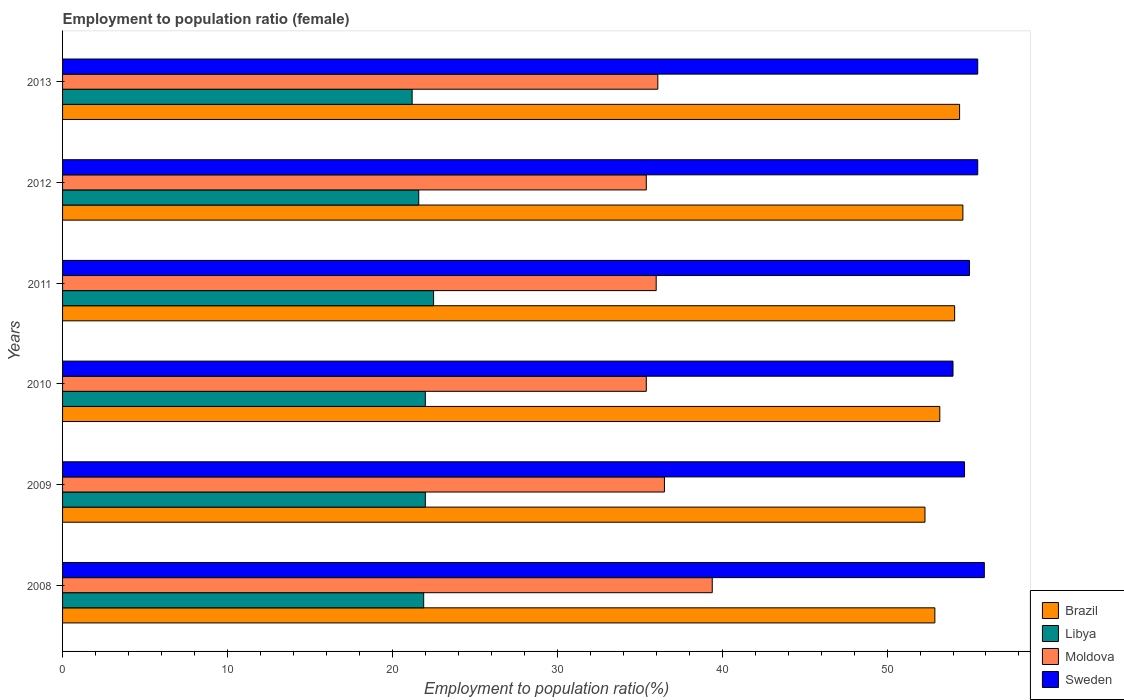Are the number of bars on each tick of the Y-axis equal?
Offer a very short reply. Yes. How many bars are there on the 3rd tick from the top?
Your answer should be very brief. 4. How many bars are there on the 4th tick from the bottom?
Give a very brief answer. 4. In how many cases, is the number of bars for a given year not equal to the number of legend labels?
Offer a very short reply. 0. What is the employment to population ratio in Brazil in 2011?
Provide a succinct answer. 54.1. Across all years, what is the minimum employment to population ratio in Brazil?
Offer a very short reply. 52.3. In which year was the employment to population ratio in Moldova maximum?
Your answer should be very brief. 2008. What is the total employment to population ratio in Sweden in the graph?
Provide a short and direct response. 330.6. What is the difference between the employment to population ratio in Brazil in 2012 and that in 2013?
Provide a short and direct response. 0.2. What is the difference between the employment to population ratio in Brazil in 2011 and the employment to population ratio in Moldova in 2012?
Keep it short and to the point. 18.7. What is the average employment to population ratio in Sweden per year?
Provide a short and direct response. 55.1. In the year 2009, what is the difference between the employment to population ratio in Libya and employment to population ratio in Sweden?
Make the answer very short. -32.7. What is the ratio of the employment to population ratio in Libya in 2011 to that in 2013?
Your answer should be very brief. 1.06. Is the difference between the employment to population ratio in Libya in 2009 and 2011 greater than the difference between the employment to population ratio in Sweden in 2009 and 2011?
Make the answer very short. No. What is the difference between the highest and the lowest employment to population ratio in Brazil?
Make the answer very short. 2.3. In how many years, is the employment to population ratio in Moldova greater than the average employment to population ratio in Moldova taken over all years?
Give a very brief answer. 2. Is the sum of the employment to population ratio in Libya in 2008 and 2012 greater than the maximum employment to population ratio in Moldova across all years?
Ensure brevity in your answer.  Yes. What does the 2nd bar from the bottom in 2008 represents?
Offer a terse response. Libya. Is it the case that in every year, the sum of the employment to population ratio in Brazil and employment to population ratio in Moldova is greater than the employment to population ratio in Sweden?
Offer a terse response. Yes. How many bars are there?
Provide a succinct answer. 24. Are all the bars in the graph horizontal?
Offer a very short reply. Yes. What is the difference between two consecutive major ticks on the X-axis?
Your answer should be compact. 10. Does the graph contain any zero values?
Keep it short and to the point. No. Does the graph contain grids?
Make the answer very short. No. How are the legend labels stacked?
Your response must be concise. Vertical. What is the title of the graph?
Keep it short and to the point. Employment to population ratio (female). Does "Iceland" appear as one of the legend labels in the graph?
Your answer should be compact. No. What is the Employment to population ratio(%) in Brazil in 2008?
Give a very brief answer. 52.9. What is the Employment to population ratio(%) of Libya in 2008?
Ensure brevity in your answer.  21.9. What is the Employment to population ratio(%) in Moldova in 2008?
Offer a very short reply. 39.4. What is the Employment to population ratio(%) in Sweden in 2008?
Provide a short and direct response. 55.9. What is the Employment to population ratio(%) of Brazil in 2009?
Your answer should be very brief. 52.3. What is the Employment to population ratio(%) of Libya in 2009?
Give a very brief answer. 22. What is the Employment to population ratio(%) of Moldova in 2009?
Keep it short and to the point. 36.5. What is the Employment to population ratio(%) of Sweden in 2009?
Keep it short and to the point. 54.7. What is the Employment to population ratio(%) of Brazil in 2010?
Your answer should be very brief. 53.2. What is the Employment to population ratio(%) in Libya in 2010?
Keep it short and to the point. 22. What is the Employment to population ratio(%) in Moldova in 2010?
Offer a terse response. 35.4. What is the Employment to population ratio(%) of Sweden in 2010?
Make the answer very short. 54. What is the Employment to population ratio(%) of Brazil in 2011?
Provide a succinct answer. 54.1. What is the Employment to population ratio(%) of Brazil in 2012?
Provide a succinct answer. 54.6. What is the Employment to population ratio(%) in Libya in 2012?
Give a very brief answer. 21.6. What is the Employment to population ratio(%) in Moldova in 2012?
Give a very brief answer. 35.4. What is the Employment to population ratio(%) of Sweden in 2012?
Provide a short and direct response. 55.5. What is the Employment to population ratio(%) of Brazil in 2013?
Your response must be concise. 54.4. What is the Employment to population ratio(%) of Libya in 2013?
Your answer should be very brief. 21.2. What is the Employment to population ratio(%) in Moldova in 2013?
Your answer should be very brief. 36.1. What is the Employment to population ratio(%) in Sweden in 2013?
Provide a short and direct response. 55.5. Across all years, what is the maximum Employment to population ratio(%) of Brazil?
Provide a succinct answer. 54.6. Across all years, what is the maximum Employment to population ratio(%) of Libya?
Make the answer very short. 22.5. Across all years, what is the maximum Employment to population ratio(%) in Moldova?
Give a very brief answer. 39.4. Across all years, what is the maximum Employment to population ratio(%) in Sweden?
Your answer should be very brief. 55.9. Across all years, what is the minimum Employment to population ratio(%) of Brazil?
Provide a short and direct response. 52.3. Across all years, what is the minimum Employment to population ratio(%) of Libya?
Offer a very short reply. 21.2. Across all years, what is the minimum Employment to population ratio(%) of Moldova?
Your response must be concise. 35.4. What is the total Employment to population ratio(%) in Brazil in the graph?
Your answer should be compact. 321.5. What is the total Employment to population ratio(%) of Libya in the graph?
Offer a very short reply. 131.2. What is the total Employment to population ratio(%) in Moldova in the graph?
Ensure brevity in your answer.  218.8. What is the total Employment to population ratio(%) of Sweden in the graph?
Your answer should be very brief. 330.6. What is the difference between the Employment to population ratio(%) of Sweden in 2008 and that in 2009?
Offer a terse response. 1.2. What is the difference between the Employment to population ratio(%) in Moldova in 2008 and that in 2010?
Offer a very short reply. 4. What is the difference between the Employment to population ratio(%) in Brazil in 2008 and that in 2012?
Offer a very short reply. -1.7. What is the difference between the Employment to population ratio(%) in Brazil in 2008 and that in 2013?
Provide a succinct answer. -1.5. What is the difference between the Employment to population ratio(%) in Brazil in 2009 and that in 2010?
Make the answer very short. -0.9. What is the difference between the Employment to population ratio(%) of Libya in 2009 and that in 2010?
Keep it short and to the point. 0. What is the difference between the Employment to population ratio(%) of Moldova in 2009 and that in 2010?
Your response must be concise. 1.1. What is the difference between the Employment to population ratio(%) in Sweden in 2009 and that in 2010?
Your answer should be compact. 0.7. What is the difference between the Employment to population ratio(%) in Brazil in 2009 and that in 2012?
Your response must be concise. -2.3. What is the difference between the Employment to population ratio(%) in Libya in 2009 and that in 2012?
Ensure brevity in your answer.  0.4. What is the difference between the Employment to population ratio(%) in Moldova in 2009 and that in 2012?
Offer a very short reply. 1.1. What is the difference between the Employment to population ratio(%) in Moldova in 2009 and that in 2013?
Ensure brevity in your answer.  0.4. What is the difference between the Employment to population ratio(%) in Sweden in 2009 and that in 2013?
Offer a terse response. -0.8. What is the difference between the Employment to population ratio(%) in Libya in 2010 and that in 2011?
Give a very brief answer. -0.5. What is the difference between the Employment to population ratio(%) of Moldova in 2010 and that in 2011?
Make the answer very short. -0.6. What is the difference between the Employment to population ratio(%) in Brazil in 2010 and that in 2012?
Your response must be concise. -1.4. What is the difference between the Employment to population ratio(%) of Libya in 2010 and that in 2013?
Offer a terse response. 0.8. What is the difference between the Employment to population ratio(%) in Sweden in 2010 and that in 2013?
Keep it short and to the point. -1.5. What is the difference between the Employment to population ratio(%) of Sweden in 2011 and that in 2012?
Give a very brief answer. -0.5. What is the difference between the Employment to population ratio(%) in Brazil in 2011 and that in 2013?
Offer a very short reply. -0.3. What is the difference between the Employment to population ratio(%) of Libya in 2011 and that in 2013?
Keep it short and to the point. 1.3. What is the difference between the Employment to population ratio(%) of Moldova in 2011 and that in 2013?
Make the answer very short. -0.1. What is the difference between the Employment to population ratio(%) of Sweden in 2011 and that in 2013?
Provide a succinct answer. -0.5. What is the difference between the Employment to population ratio(%) in Libya in 2012 and that in 2013?
Ensure brevity in your answer.  0.4. What is the difference between the Employment to population ratio(%) in Brazil in 2008 and the Employment to population ratio(%) in Libya in 2009?
Make the answer very short. 30.9. What is the difference between the Employment to population ratio(%) in Brazil in 2008 and the Employment to population ratio(%) in Sweden in 2009?
Your answer should be very brief. -1.8. What is the difference between the Employment to population ratio(%) in Libya in 2008 and the Employment to population ratio(%) in Moldova in 2009?
Provide a succinct answer. -14.6. What is the difference between the Employment to population ratio(%) in Libya in 2008 and the Employment to population ratio(%) in Sweden in 2009?
Offer a very short reply. -32.8. What is the difference between the Employment to population ratio(%) of Moldova in 2008 and the Employment to population ratio(%) of Sweden in 2009?
Provide a short and direct response. -15.3. What is the difference between the Employment to population ratio(%) in Brazil in 2008 and the Employment to population ratio(%) in Libya in 2010?
Your answer should be compact. 30.9. What is the difference between the Employment to population ratio(%) of Brazil in 2008 and the Employment to population ratio(%) of Sweden in 2010?
Offer a very short reply. -1.1. What is the difference between the Employment to population ratio(%) in Libya in 2008 and the Employment to population ratio(%) in Sweden in 2010?
Offer a very short reply. -32.1. What is the difference between the Employment to population ratio(%) in Moldova in 2008 and the Employment to population ratio(%) in Sweden in 2010?
Provide a succinct answer. -14.6. What is the difference between the Employment to population ratio(%) of Brazil in 2008 and the Employment to population ratio(%) of Libya in 2011?
Make the answer very short. 30.4. What is the difference between the Employment to population ratio(%) in Libya in 2008 and the Employment to population ratio(%) in Moldova in 2011?
Make the answer very short. -14.1. What is the difference between the Employment to population ratio(%) of Libya in 2008 and the Employment to population ratio(%) of Sweden in 2011?
Offer a terse response. -33.1. What is the difference between the Employment to population ratio(%) in Moldova in 2008 and the Employment to population ratio(%) in Sweden in 2011?
Ensure brevity in your answer.  -15.6. What is the difference between the Employment to population ratio(%) in Brazil in 2008 and the Employment to population ratio(%) in Libya in 2012?
Keep it short and to the point. 31.3. What is the difference between the Employment to population ratio(%) of Libya in 2008 and the Employment to population ratio(%) of Sweden in 2012?
Ensure brevity in your answer.  -33.6. What is the difference between the Employment to population ratio(%) of Moldova in 2008 and the Employment to population ratio(%) of Sweden in 2012?
Make the answer very short. -16.1. What is the difference between the Employment to population ratio(%) of Brazil in 2008 and the Employment to population ratio(%) of Libya in 2013?
Your answer should be compact. 31.7. What is the difference between the Employment to population ratio(%) of Brazil in 2008 and the Employment to population ratio(%) of Sweden in 2013?
Offer a terse response. -2.6. What is the difference between the Employment to population ratio(%) in Libya in 2008 and the Employment to population ratio(%) in Sweden in 2013?
Your response must be concise. -33.6. What is the difference between the Employment to population ratio(%) in Moldova in 2008 and the Employment to population ratio(%) in Sweden in 2013?
Give a very brief answer. -16.1. What is the difference between the Employment to population ratio(%) in Brazil in 2009 and the Employment to population ratio(%) in Libya in 2010?
Provide a succinct answer. 30.3. What is the difference between the Employment to population ratio(%) in Brazil in 2009 and the Employment to population ratio(%) in Moldova in 2010?
Make the answer very short. 16.9. What is the difference between the Employment to population ratio(%) of Libya in 2009 and the Employment to population ratio(%) of Sweden in 2010?
Give a very brief answer. -32. What is the difference between the Employment to population ratio(%) in Moldova in 2009 and the Employment to population ratio(%) in Sweden in 2010?
Offer a very short reply. -17.5. What is the difference between the Employment to population ratio(%) in Brazil in 2009 and the Employment to population ratio(%) in Libya in 2011?
Give a very brief answer. 29.8. What is the difference between the Employment to population ratio(%) in Brazil in 2009 and the Employment to population ratio(%) in Moldova in 2011?
Your response must be concise. 16.3. What is the difference between the Employment to population ratio(%) in Brazil in 2009 and the Employment to population ratio(%) in Sweden in 2011?
Give a very brief answer. -2.7. What is the difference between the Employment to population ratio(%) in Libya in 2009 and the Employment to population ratio(%) in Sweden in 2011?
Your answer should be very brief. -33. What is the difference between the Employment to population ratio(%) of Moldova in 2009 and the Employment to population ratio(%) of Sweden in 2011?
Ensure brevity in your answer.  -18.5. What is the difference between the Employment to population ratio(%) of Brazil in 2009 and the Employment to population ratio(%) of Libya in 2012?
Your answer should be very brief. 30.7. What is the difference between the Employment to population ratio(%) in Brazil in 2009 and the Employment to population ratio(%) in Moldova in 2012?
Provide a short and direct response. 16.9. What is the difference between the Employment to population ratio(%) of Brazil in 2009 and the Employment to population ratio(%) of Sweden in 2012?
Give a very brief answer. -3.2. What is the difference between the Employment to population ratio(%) of Libya in 2009 and the Employment to population ratio(%) of Sweden in 2012?
Offer a terse response. -33.5. What is the difference between the Employment to population ratio(%) of Brazil in 2009 and the Employment to population ratio(%) of Libya in 2013?
Ensure brevity in your answer.  31.1. What is the difference between the Employment to population ratio(%) in Libya in 2009 and the Employment to population ratio(%) in Moldova in 2013?
Offer a terse response. -14.1. What is the difference between the Employment to population ratio(%) in Libya in 2009 and the Employment to population ratio(%) in Sweden in 2013?
Ensure brevity in your answer.  -33.5. What is the difference between the Employment to population ratio(%) in Brazil in 2010 and the Employment to population ratio(%) in Libya in 2011?
Your answer should be compact. 30.7. What is the difference between the Employment to population ratio(%) in Brazil in 2010 and the Employment to population ratio(%) in Moldova in 2011?
Make the answer very short. 17.2. What is the difference between the Employment to population ratio(%) in Brazil in 2010 and the Employment to population ratio(%) in Sweden in 2011?
Offer a very short reply. -1.8. What is the difference between the Employment to population ratio(%) of Libya in 2010 and the Employment to population ratio(%) of Sweden in 2011?
Give a very brief answer. -33. What is the difference between the Employment to population ratio(%) in Moldova in 2010 and the Employment to population ratio(%) in Sweden in 2011?
Your answer should be very brief. -19.6. What is the difference between the Employment to population ratio(%) of Brazil in 2010 and the Employment to population ratio(%) of Libya in 2012?
Make the answer very short. 31.6. What is the difference between the Employment to population ratio(%) in Brazil in 2010 and the Employment to population ratio(%) in Sweden in 2012?
Ensure brevity in your answer.  -2.3. What is the difference between the Employment to population ratio(%) of Libya in 2010 and the Employment to population ratio(%) of Moldova in 2012?
Offer a terse response. -13.4. What is the difference between the Employment to population ratio(%) in Libya in 2010 and the Employment to population ratio(%) in Sweden in 2012?
Provide a short and direct response. -33.5. What is the difference between the Employment to population ratio(%) of Moldova in 2010 and the Employment to population ratio(%) of Sweden in 2012?
Make the answer very short. -20.1. What is the difference between the Employment to population ratio(%) in Libya in 2010 and the Employment to population ratio(%) in Moldova in 2013?
Offer a very short reply. -14.1. What is the difference between the Employment to population ratio(%) of Libya in 2010 and the Employment to population ratio(%) of Sweden in 2013?
Give a very brief answer. -33.5. What is the difference between the Employment to population ratio(%) of Moldova in 2010 and the Employment to population ratio(%) of Sweden in 2013?
Keep it short and to the point. -20.1. What is the difference between the Employment to population ratio(%) in Brazil in 2011 and the Employment to population ratio(%) in Libya in 2012?
Offer a very short reply. 32.5. What is the difference between the Employment to population ratio(%) in Brazil in 2011 and the Employment to population ratio(%) in Sweden in 2012?
Your answer should be very brief. -1.4. What is the difference between the Employment to population ratio(%) of Libya in 2011 and the Employment to population ratio(%) of Sweden in 2012?
Your answer should be compact. -33. What is the difference between the Employment to population ratio(%) in Moldova in 2011 and the Employment to population ratio(%) in Sweden in 2012?
Provide a succinct answer. -19.5. What is the difference between the Employment to population ratio(%) in Brazil in 2011 and the Employment to population ratio(%) in Libya in 2013?
Your answer should be compact. 32.9. What is the difference between the Employment to population ratio(%) in Libya in 2011 and the Employment to population ratio(%) in Moldova in 2013?
Make the answer very short. -13.6. What is the difference between the Employment to population ratio(%) of Libya in 2011 and the Employment to population ratio(%) of Sweden in 2013?
Your answer should be very brief. -33. What is the difference between the Employment to population ratio(%) in Moldova in 2011 and the Employment to population ratio(%) in Sweden in 2013?
Your answer should be very brief. -19.5. What is the difference between the Employment to population ratio(%) in Brazil in 2012 and the Employment to population ratio(%) in Libya in 2013?
Ensure brevity in your answer.  33.4. What is the difference between the Employment to population ratio(%) of Libya in 2012 and the Employment to population ratio(%) of Moldova in 2013?
Ensure brevity in your answer.  -14.5. What is the difference between the Employment to population ratio(%) of Libya in 2012 and the Employment to population ratio(%) of Sweden in 2013?
Offer a terse response. -33.9. What is the difference between the Employment to population ratio(%) in Moldova in 2012 and the Employment to population ratio(%) in Sweden in 2013?
Offer a very short reply. -20.1. What is the average Employment to population ratio(%) of Brazil per year?
Ensure brevity in your answer.  53.58. What is the average Employment to population ratio(%) in Libya per year?
Your answer should be compact. 21.87. What is the average Employment to population ratio(%) of Moldova per year?
Give a very brief answer. 36.47. What is the average Employment to population ratio(%) in Sweden per year?
Provide a succinct answer. 55.1. In the year 2008, what is the difference between the Employment to population ratio(%) of Brazil and Employment to population ratio(%) of Libya?
Ensure brevity in your answer.  31. In the year 2008, what is the difference between the Employment to population ratio(%) in Libya and Employment to population ratio(%) in Moldova?
Your response must be concise. -17.5. In the year 2008, what is the difference between the Employment to population ratio(%) of Libya and Employment to population ratio(%) of Sweden?
Give a very brief answer. -34. In the year 2008, what is the difference between the Employment to population ratio(%) of Moldova and Employment to population ratio(%) of Sweden?
Make the answer very short. -16.5. In the year 2009, what is the difference between the Employment to population ratio(%) in Brazil and Employment to population ratio(%) in Libya?
Offer a very short reply. 30.3. In the year 2009, what is the difference between the Employment to population ratio(%) of Brazil and Employment to population ratio(%) of Moldova?
Your response must be concise. 15.8. In the year 2009, what is the difference between the Employment to population ratio(%) in Libya and Employment to population ratio(%) in Moldova?
Give a very brief answer. -14.5. In the year 2009, what is the difference between the Employment to population ratio(%) of Libya and Employment to population ratio(%) of Sweden?
Ensure brevity in your answer.  -32.7. In the year 2009, what is the difference between the Employment to population ratio(%) of Moldova and Employment to population ratio(%) of Sweden?
Offer a terse response. -18.2. In the year 2010, what is the difference between the Employment to population ratio(%) in Brazil and Employment to population ratio(%) in Libya?
Offer a very short reply. 31.2. In the year 2010, what is the difference between the Employment to population ratio(%) of Libya and Employment to population ratio(%) of Moldova?
Your response must be concise. -13.4. In the year 2010, what is the difference between the Employment to population ratio(%) in Libya and Employment to population ratio(%) in Sweden?
Provide a short and direct response. -32. In the year 2010, what is the difference between the Employment to population ratio(%) in Moldova and Employment to population ratio(%) in Sweden?
Give a very brief answer. -18.6. In the year 2011, what is the difference between the Employment to population ratio(%) in Brazil and Employment to population ratio(%) in Libya?
Give a very brief answer. 31.6. In the year 2011, what is the difference between the Employment to population ratio(%) of Brazil and Employment to population ratio(%) of Moldova?
Offer a terse response. 18.1. In the year 2011, what is the difference between the Employment to population ratio(%) in Libya and Employment to population ratio(%) in Moldova?
Your response must be concise. -13.5. In the year 2011, what is the difference between the Employment to population ratio(%) of Libya and Employment to population ratio(%) of Sweden?
Ensure brevity in your answer.  -32.5. In the year 2012, what is the difference between the Employment to population ratio(%) in Brazil and Employment to population ratio(%) in Sweden?
Offer a very short reply. -0.9. In the year 2012, what is the difference between the Employment to population ratio(%) in Libya and Employment to population ratio(%) in Moldova?
Make the answer very short. -13.8. In the year 2012, what is the difference between the Employment to population ratio(%) of Libya and Employment to population ratio(%) of Sweden?
Keep it short and to the point. -33.9. In the year 2012, what is the difference between the Employment to population ratio(%) in Moldova and Employment to population ratio(%) in Sweden?
Make the answer very short. -20.1. In the year 2013, what is the difference between the Employment to population ratio(%) in Brazil and Employment to population ratio(%) in Libya?
Your answer should be compact. 33.2. In the year 2013, what is the difference between the Employment to population ratio(%) in Brazil and Employment to population ratio(%) in Moldova?
Your answer should be compact. 18.3. In the year 2013, what is the difference between the Employment to population ratio(%) in Libya and Employment to population ratio(%) in Moldova?
Provide a short and direct response. -14.9. In the year 2013, what is the difference between the Employment to population ratio(%) of Libya and Employment to population ratio(%) of Sweden?
Keep it short and to the point. -34.3. In the year 2013, what is the difference between the Employment to population ratio(%) of Moldova and Employment to population ratio(%) of Sweden?
Offer a very short reply. -19.4. What is the ratio of the Employment to population ratio(%) of Brazil in 2008 to that in 2009?
Keep it short and to the point. 1.01. What is the ratio of the Employment to population ratio(%) in Moldova in 2008 to that in 2009?
Keep it short and to the point. 1.08. What is the ratio of the Employment to population ratio(%) in Sweden in 2008 to that in 2009?
Give a very brief answer. 1.02. What is the ratio of the Employment to population ratio(%) of Brazil in 2008 to that in 2010?
Provide a succinct answer. 0.99. What is the ratio of the Employment to population ratio(%) in Moldova in 2008 to that in 2010?
Your answer should be very brief. 1.11. What is the ratio of the Employment to population ratio(%) of Sweden in 2008 to that in 2010?
Keep it short and to the point. 1.04. What is the ratio of the Employment to population ratio(%) in Brazil in 2008 to that in 2011?
Offer a terse response. 0.98. What is the ratio of the Employment to population ratio(%) in Libya in 2008 to that in 2011?
Offer a terse response. 0.97. What is the ratio of the Employment to population ratio(%) of Moldova in 2008 to that in 2011?
Ensure brevity in your answer.  1.09. What is the ratio of the Employment to population ratio(%) of Sweden in 2008 to that in 2011?
Offer a terse response. 1.02. What is the ratio of the Employment to population ratio(%) of Brazil in 2008 to that in 2012?
Your response must be concise. 0.97. What is the ratio of the Employment to population ratio(%) in Libya in 2008 to that in 2012?
Offer a terse response. 1.01. What is the ratio of the Employment to population ratio(%) of Moldova in 2008 to that in 2012?
Provide a succinct answer. 1.11. What is the ratio of the Employment to population ratio(%) in Brazil in 2008 to that in 2013?
Your answer should be compact. 0.97. What is the ratio of the Employment to population ratio(%) in Libya in 2008 to that in 2013?
Keep it short and to the point. 1.03. What is the ratio of the Employment to population ratio(%) in Moldova in 2008 to that in 2013?
Offer a very short reply. 1.09. What is the ratio of the Employment to population ratio(%) of Sweden in 2008 to that in 2013?
Your response must be concise. 1.01. What is the ratio of the Employment to population ratio(%) of Brazil in 2009 to that in 2010?
Keep it short and to the point. 0.98. What is the ratio of the Employment to population ratio(%) in Libya in 2009 to that in 2010?
Your answer should be compact. 1. What is the ratio of the Employment to population ratio(%) of Moldova in 2009 to that in 2010?
Make the answer very short. 1.03. What is the ratio of the Employment to population ratio(%) in Brazil in 2009 to that in 2011?
Offer a very short reply. 0.97. What is the ratio of the Employment to population ratio(%) of Libya in 2009 to that in 2011?
Provide a succinct answer. 0.98. What is the ratio of the Employment to population ratio(%) in Moldova in 2009 to that in 2011?
Provide a short and direct response. 1.01. What is the ratio of the Employment to population ratio(%) of Brazil in 2009 to that in 2012?
Keep it short and to the point. 0.96. What is the ratio of the Employment to population ratio(%) of Libya in 2009 to that in 2012?
Offer a terse response. 1.02. What is the ratio of the Employment to population ratio(%) in Moldova in 2009 to that in 2012?
Ensure brevity in your answer.  1.03. What is the ratio of the Employment to population ratio(%) of Sweden in 2009 to that in 2012?
Your answer should be very brief. 0.99. What is the ratio of the Employment to population ratio(%) of Brazil in 2009 to that in 2013?
Provide a succinct answer. 0.96. What is the ratio of the Employment to population ratio(%) of Libya in 2009 to that in 2013?
Make the answer very short. 1.04. What is the ratio of the Employment to population ratio(%) of Moldova in 2009 to that in 2013?
Provide a short and direct response. 1.01. What is the ratio of the Employment to population ratio(%) of Sweden in 2009 to that in 2013?
Provide a short and direct response. 0.99. What is the ratio of the Employment to population ratio(%) of Brazil in 2010 to that in 2011?
Provide a short and direct response. 0.98. What is the ratio of the Employment to population ratio(%) of Libya in 2010 to that in 2011?
Keep it short and to the point. 0.98. What is the ratio of the Employment to population ratio(%) of Moldova in 2010 to that in 2011?
Make the answer very short. 0.98. What is the ratio of the Employment to population ratio(%) in Sweden in 2010 to that in 2011?
Offer a terse response. 0.98. What is the ratio of the Employment to population ratio(%) in Brazil in 2010 to that in 2012?
Provide a succinct answer. 0.97. What is the ratio of the Employment to population ratio(%) of Libya in 2010 to that in 2012?
Offer a terse response. 1.02. What is the ratio of the Employment to population ratio(%) in Moldova in 2010 to that in 2012?
Your response must be concise. 1. What is the ratio of the Employment to population ratio(%) in Sweden in 2010 to that in 2012?
Provide a short and direct response. 0.97. What is the ratio of the Employment to population ratio(%) in Brazil in 2010 to that in 2013?
Offer a terse response. 0.98. What is the ratio of the Employment to population ratio(%) in Libya in 2010 to that in 2013?
Give a very brief answer. 1.04. What is the ratio of the Employment to population ratio(%) in Moldova in 2010 to that in 2013?
Keep it short and to the point. 0.98. What is the ratio of the Employment to population ratio(%) in Brazil in 2011 to that in 2012?
Give a very brief answer. 0.99. What is the ratio of the Employment to population ratio(%) of Libya in 2011 to that in 2012?
Your response must be concise. 1.04. What is the ratio of the Employment to population ratio(%) in Moldova in 2011 to that in 2012?
Ensure brevity in your answer.  1.02. What is the ratio of the Employment to population ratio(%) of Libya in 2011 to that in 2013?
Offer a terse response. 1.06. What is the ratio of the Employment to population ratio(%) in Libya in 2012 to that in 2013?
Offer a terse response. 1.02. What is the ratio of the Employment to population ratio(%) of Moldova in 2012 to that in 2013?
Offer a terse response. 0.98. What is the difference between the highest and the second highest Employment to population ratio(%) of Libya?
Make the answer very short. 0.5. What is the difference between the highest and the second highest Employment to population ratio(%) of Moldova?
Offer a very short reply. 2.9. What is the difference between the highest and the lowest Employment to population ratio(%) in Libya?
Offer a terse response. 1.3. What is the difference between the highest and the lowest Employment to population ratio(%) in Moldova?
Your answer should be very brief. 4. What is the difference between the highest and the lowest Employment to population ratio(%) of Sweden?
Ensure brevity in your answer.  1.9. 